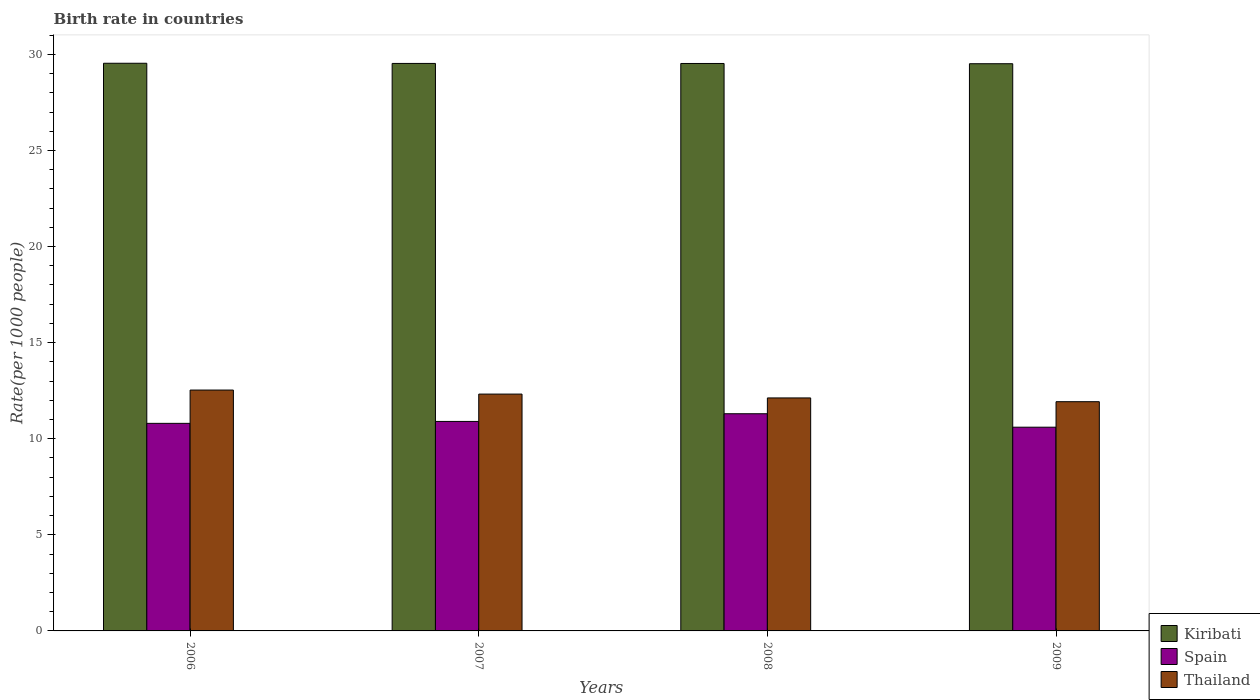How many different coloured bars are there?
Offer a terse response. 3. Are the number of bars per tick equal to the number of legend labels?
Offer a very short reply. Yes. Are the number of bars on each tick of the X-axis equal?
Provide a short and direct response. Yes. How many bars are there on the 2nd tick from the left?
Make the answer very short. 3. What is the label of the 1st group of bars from the left?
Offer a terse response. 2006. What is the birth rate in Thailand in 2009?
Provide a short and direct response. 11.93. Across all years, what is the maximum birth rate in Thailand?
Offer a very short reply. 12.53. Across all years, what is the minimum birth rate in Kiribati?
Offer a terse response. 29.51. In which year was the birth rate in Thailand minimum?
Make the answer very short. 2009. What is the total birth rate in Thailand in the graph?
Keep it short and to the point. 48.91. What is the difference between the birth rate in Spain in 2007 and that in 2008?
Offer a very short reply. -0.4. What is the difference between the birth rate in Kiribati in 2007 and the birth rate in Spain in 2008?
Ensure brevity in your answer.  18.23. What is the average birth rate in Thailand per year?
Your answer should be very brief. 12.23. In the year 2009, what is the difference between the birth rate in Thailand and birth rate in Spain?
Provide a succinct answer. 1.33. What is the ratio of the birth rate in Spain in 2006 to that in 2007?
Give a very brief answer. 0.99. Is the difference between the birth rate in Thailand in 2007 and 2008 greater than the difference between the birth rate in Spain in 2007 and 2008?
Offer a terse response. Yes. What is the difference between the highest and the second highest birth rate in Kiribati?
Give a very brief answer. 0.01. What is the difference between the highest and the lowest birth rate in Thailand?
Make the answer very short. 0.61. In how many years, is the birth rate in Spain greater than the average birth rate in Spain taken over all years?
Provide a succinct answer. 1. What does the 2nd bar from the left in 2008 represents?
Give a very brief answer. Spain. How many years are there in the graph?
Your answer should be compact. 4. Does the graph contain any zero values?
Your answer should be compact. No. Does the graph contain grids?
Your response must be concise. No. How are the legend labels stacked?
Ensure brevity in your answer.  Vertical. What is the title of the graph?
Keep it short and to the point. Birth rate in countries. What is the label or title of the X-axis?
Give a very brief answer. Years. What is the label or title of the Y-axis?
Your answer should be very brief. Rate(per 1000 people). What is the Rate(per 1000 people) in Kiribati in 2006?
Keep it short and to the point. 29.54. What is the Rate(per 1000 people) of Thailand in 2006?
Provide a succinct answer. 12.53. What is the Rate(per 1000 people) of Kiribati in 2007?
Give a very brief answer. 29.53. What is the Rate(per 1000 people) in Thailand in 2007?
Your response must be concise. 12.32. What is the Rate(per 1000 people) of Kiribati in 2008?
Give a very brief answer. 29.53. What is the Rate(per 1000 people) of Thailand in 2008?
Offer a very short reply. 12.12. What is the Rate(per 1000 people) in Kiribati in 2009?
Offer a very short reply. 29.51. What is the Rate(per 1000 people) in Thailand in 2009?
Provide a succinct answer. 11.93. Across all years, what is the maximum Rate(per 1000 people) in Kiribati?
Your answer should be compact. 29.54. Across all years, what is the maximum Rate(per 1000 people) of Spain?
Provide a succinct answer. 11.3. Across all years, what is the maximum Rate(per 1000 people) of Thailand?
Provide a short and direct response. 12.53. Across all years, what is the minimum Rate(per 1000 people) in Kiribati?
Make the answer very short. 29.51. Across all years, what is the minimum Rate(per 1000 people) in Thailand?
Give a very brief answer. 11.93. What is the total Rate(per 1000 people) in Kiribati in the graph?
Give a very brief answer. 118.1. What is the total Rate(per 1000 people) in Spain in the graph?
Your answer should be compact. 43.6. What is the total Rate(per 1000 people) in Thailand in the graph?
Your answer should be very brief. 48.91. What is the difference between the Rate(per 1000 people) of Kiribati in 2006 and that in 2007?
Your answer should be very brief. 0.01. What is the difference between the Rate(per 1000 people) of Spain in 2006 and that in 2007?
Your response must be concise. -0.1. What is the difference between the Rate(per 1000 people) of Thailand in 2006 and that in 2007?
Your response must be concise. 0.21. What is the difference between the Rate(per 1000 people) in Kiribati in 2006 and that in 2008?
Make the answer very short. 0.01. What is the difference between the Rate(per 1000 people) in Thailand in 2006 and that in 2008?
Give a very brief answer. 0.41. What is the difference between the Rate(per 1000 people) in Kiribati in 2006 and that in 2009?
Make the answer very short. 0.02. What is the difference between the Rate(per 1000 people) of Thailand in 2006 and that in 2009?
Your answer should be compact. 0.61. What is the difference between the Rate(per 1000 people) of Kiribati in 2007 and that in 2008?
Offer a terse response. 0. What is the difference between the Rate(per 1000 people) in Thailand in 2007 and that in 2008?
Offer a very short reply. 0.2. What is the difference between the Rate(per 1000 people) of Kiribati in 2007 and that in 2009?
Offer a terse response. 0.01. What is the difference between the Rate(per 1000 people) in Thailand in 2007 and that in 2009?
Offer a very short reply. 0.4. What is the difference between the Rate(per 1000 people) in Kiribati in 2008 and that in 2009?
Your answer should be very brief. 0.01. What is the difference between the Rate(per 1000 people) in Thailand in 2008 and that in 2009?
Provide a short and direct response. 0.2. What is the difference between the Rate(per 1000 people) of Kiribati in 2006 and the Rate(per 1000 people) of Spain in 2007?
Your answer should be compact. 18.64. What is the difference between the Rate(per 1000 people) in Kiribati in 2006 and the Rate(per 1000 people) in Thailand in 2007?
Your response must be concise. 17.21. What is the difference between the Rate(per 1000 people) in Spain in 2006 and the Rate(per 1000 people) in Thailand in 2007?
Offer a terse response. -1.52. What is the difference between the Rate(per 1000 people) in Kiribati in 2006 and the Rate(per 1000 people) in Spain in 2008?
Keep it short and to the point. 18.24. What is the difference between the Rate(per 1000 people) of Kiribati in 2006 and the Rate(per 1000 people) of Thailand in 2008?
Give a very brief answer. 17.41. What is the difference between the Rate(per 1000 people) of Spain in 2006 and the Rate(per 1000 people) of Thailand in 2008?
Give a very brief answer. -1.32. What is the difference between the Rate(per 1000 people) in Kiribati in 2006 and the Rate(per 1000 people) in Spain in 2009?
Ensure brevity in your answer.  18.94. What is the difference between the Rate(per 1000 people) in Kiribati in 2006 and the Rate(per 1000 people) in Thailand in 2009?
Keep it short and to the point. 17.61. What is the difference between the Rate(per 1000 people) of Spain in 2006 and the Rate(per 1000 people) of Thailand in 2009?
Your answer should be very brief. -1.13. What is the difference between the Rate(per 1000 people) of Kiribati in 2007 and the Rate(per 1000 people) of Spain in 2008?
Offer a very short reply. 18.23. What is the difference between the Rate(per 1000 people) of Kiribati in 2007 and the Rate(per 1000 people) of Thailand in 2008?
Your answer should be very brief. 17.41. What is the difference between the Rate(per 1000 people) in Spain in 2007 and the Rate(per 1000 people) in Thailand in 2008?
Make the answer very short. -1.22. What is the difference between the Rate(per 1000 people) of Kiribati in 2007 and the Rate(per 1000 people) of Spain in 2009?
Provide a succinct answer. 18.93. What is the difference between the Rate(per 1000 people) of Kiribati in 2007 and the Rate(per 1000 people) of Thailand in 2009?
Your response must be concise. 17.6. What is the difference between the Rate(per 1000 people) of Spain in 2007 and the Rate(per 1000 people) of Thailand in 2009?
Make the answer very short. -1.03. What is the difference between the Rate(per 1000 people) in Kiribati in 2008 and the Rate(per 1000 people) in Spain in 2009?
Provide a short and direct response. 18.93. What is the difference between the Rate(per 1000 people) of Kiribati in 2008 and the Rate(per 1000 people) of Thailand in 2009?
Offer a terse response. 17.6. What is the difference between the Rate(per 1000 people) of Spain in 2008 and the Rate(per 1000 people) of Thailand in 2009?
Provide a short and direct response. -0.63. What is the average Rate(per 1000 people) of Kiribati per year?
Keep it short and to the point. 29.53. What is the average Rate(per 1000 people) of Spain per year?
Your response must be concise. 10.9. What is the average Rate(per 1000 people) in Thailand per year?
Offer a very short reply. 12.23. In the year 2006, what is the difference between the Rate(per 1000 people) in Kiribati and Rate(per 1000 people) in Spain?
Your answer should be very brief. 18.74. In the year 2006, what is the difference between the Rate(per 1000 people) in Kiribati and Rate(per 1000 people) in Thailand?
Your response must be concise. 17. In the year 2006, what is the difference between the Rate(per 1000 people) in Spain and Rate(per 1000 people) in Thailand?
Make the answer very short. -1.73. In the year 2007, what is the difference between the Rate(per 1000 people) of Kiribati and Rate(per 1000 people) of Spain?
Offer a terse response. 18.63. In the year 2007, what is the difference between the Rate(per 1000 people) of Kiribati and Rate(per 1000 people) of Thailand?
Your answer should be compact. 17.2. In the year 2007, what is the difference between the Rate(per 1000 people) in Spain and Rate(per 1000 people) in Thailand?
Your response must be concise. -1.42. In the year 2008, what is the difference between the Rate(per 1000 people) of Kiribati and Rate(per 1000 people) of Spain?
Make the answer very short. 18.23. In the year 2008, what is the difference between the Rate(per 1000 people) in Kiribati and Rate(per 1000 people) in Thailand?
Keep it short and to the point. 17.4. In the year 2008, what is the difference between the Rate(per 1000 people) in Spain and Rate(per 1000 people) in Thailand?
Your answer should be very brief. -0.82. In the year 2009, what is the difference between the Rate(per 1000 people) in Kiribati and Rate(per 1000 people) in Spain?
Your answer should be compact. 18.91. In the year 2009, what is the difference between the Rate(per 1000 people) in Kiribati and Rate(per 1000 people) in Thailand?
Keep it short and to the point. 17.59. In the year 2009, what is the difference between the Rate(per 1000 people) in Spain and Rate(per 1000 people) in Thailand?
Offer a very short reply. -1.33. What is the ratio of the Rate(per 1000 people) in Kiribati in 2006 to that in 2007?
Provide a short and direct response. 1. What is the ratio of the Rate(per 1000 people) of Spain in 2006 to that in 2007?
Give a very brief answer. 0.99. What is the ratio of the Rate(per 1000 people) of Thailand in 2006 to that in 2007?
Give a very brief answer. 1.02. What is the ratio of the Rate(per 1000 people) of Kiribati in 2006 to that in 2008?
Provide a succinct answer. 1. What is the ratio of the Rate(per 1000 people) in Spain in 2006 to that in 2008?
Provide a succinct answer. 0.96. What is the ratio of the Rate(per 1000 people) of Thailand in 2006 to that in 2008?
Provide a short and direct response. 1.03. What is the ratio of the Rate(per 1000 people) in Spain in 2006 to that in 2009?
Make the answer very short. 1.02. What is the ratio of the Rate(per 1000 people) of Thailand in 2006 to that in 2009?
Keep it short and to the point. 1.05. What is the ratio of the Rate(per 1000 people) in Spain in 2007 to that in 2008?
Your response must be concise. 0.96. What is the ratio of the Rate(per 1000 people) of Thailand in 2007 to that in 2008?
Give a very brief answer. 1.02. What is the ratio of the Rate(per 1000 people) of Spain in 2007 to that in 2009?
Keep it short and to the point. 1.03. What is the ratio of the Rate(per 1000 people) of Thailand in 2007 to that in 2009?
Offer a terse response. 1.03. What is the ratio of the Rate(per 1000 people) in Spain in 2008 to that in 2009?
Your answer should be very brief. 1.07. What is the ratio of the Rate(per 1000 people) in Thailand in 2008 to that in 2009?
Your response must be concise. 1.02. What is the difference between the highest and the second highest Rate(per 1000 people) of Kiribati?
Your response must be concise. 0.01. What is the difference between the highest and the second highest Rate(per 1000 people) in Spain?
Keep it short and to the point. 0.4. What is the difference between the highest and the second highest Rate(per 1000 people) of Thailand?
Ensure brevity in your answer.  0.21. What is the difference between the highest and the lowest Rate(per 1000 people) in Kiribati?
Your answer should be compact. 0.02. What is the difference between the highest and the lowest Rate(per 1000 people) of Thailand?
Make the answer very short. 0.61. 